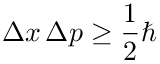<formula> <loc_0><loc_0><loc_500><loc_500>\Delta x \, \Delta p \geq { \frac { 1 } { 2 } } \hbar</formula> 